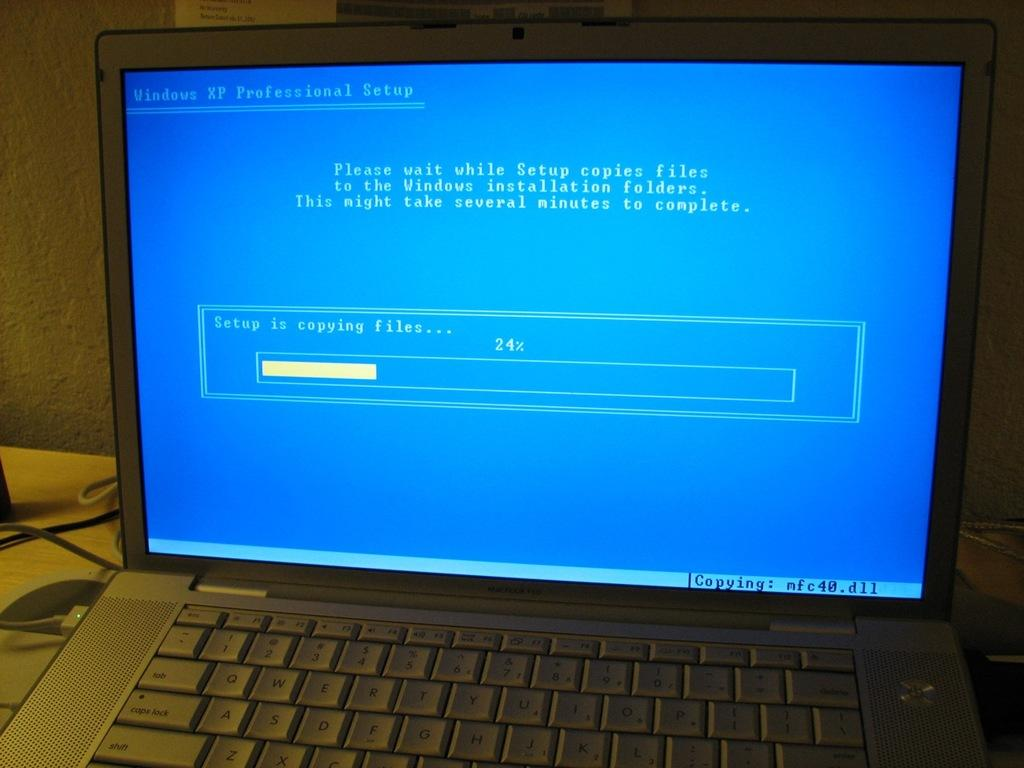<image>
Relay a brief, clear account of the picture shown. An old lap top computer has the Windows XP Professional set up screen on it. 